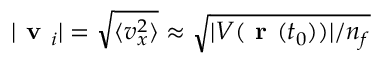<formula> <loc_0><loc_0><loc_500><loc_500>| v _ { i } | = \sqrt { \langle v _ { x } ^ { 2 } \rangle } \approx \sqrt { | V ( { r } ( t _ { 0 } ) ) | / n _ { f } }</formula> 